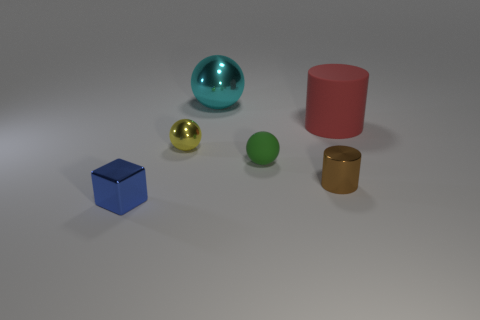Can you describe the relative positions of all the objects in the image? Sure, in the image we see six objects positioned on what looks like a surface with a gradual shadow transition. From left to right, there's a blue cube, a small golden sphere, a green sphere, a tiny brown cylinder, a large red cylinder, and a turquoise blue sphere that's reflecting some light, giving it a shiny appearance. 